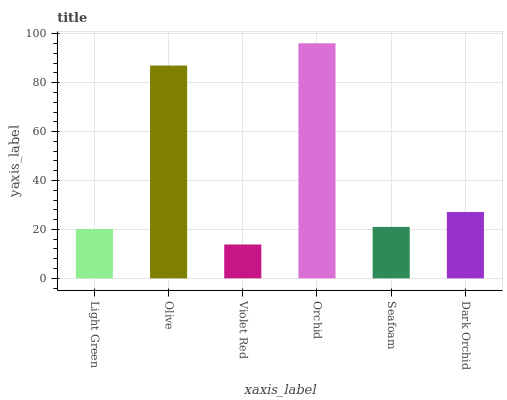Is Violet Red the minimum?
Answer yes or no. Yes. Is Orchid the maximum?
Answer yes or no. Yes. Is Olive the minimum?
Answer yes or no. No. Is Olive the maximum?
Answer yes or no. No. Is Olive greater than Light Green?
Answer yes or no. Yes. Is Light Green less than Olive?
Answer yes or no. Yes. Is Light Green greater than Olive?
Answer yes or no. No. Is Olive less than Light Green?
Answer yes or no. No. Is Dark Orchid the high median?
Answer yes or no. Yes. Is Seafoam the low median?
Answer yes or no. Yes. Is Violet Red the high median?
Answer yes or no. No. Is Olive the low median?
Answer yes or no. No. 